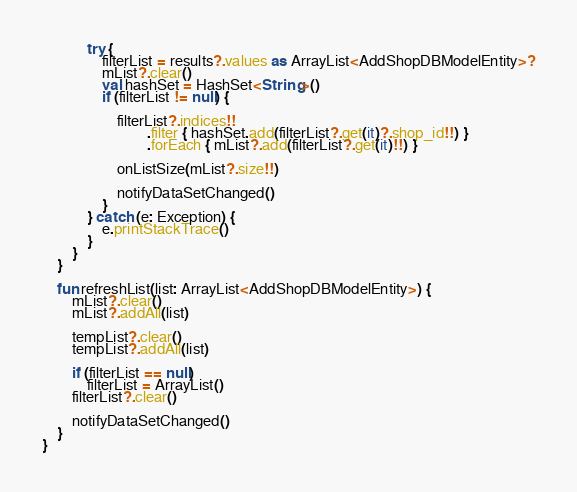<code> <loc_0><loc_0><loc_500><loc_500><_Kotlin_>
            try {
                filterList = results?.values as ArrayList<AddShopDBModelEntity>?
                mList?.clear()
                val hashSet = HashSet<String>()
                if (filterList != null) {

                    filterList?.indices!!
                            .filter { hashSet.add(filterList?.get(it)?.shop_id!!) }
                            .forEach { mList?.add(filterList?.get(it)!!) }

                    onListSize(mList?.size!!)

                    notifyDataSetChanged()
                }
            } catch (e: Exception) {
                e.printStackTrace()
            }
        }
    }

    fun refreshList(list: ArrayList<AddShopDBModelEntity>) {
        mList?.clear()
        mList?.addAll(list)

        tempList?.clear()
        tempList?.addAll(list)

        if (filterList == null)
            filterList = ArrayList()
        filterList?.clear()

        notifyDataSetChanged()
    }
}</code> 